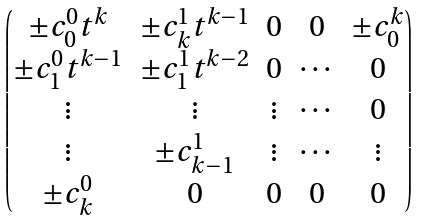<formula> <loc_0><loc_0><loc_500><loc_500>\begin{pmatrix} \pm c ^ { 0 } _ { 0 } t ^ { k } & \pm c ^ { 1 } _ { k } t ^ { k - 1 } & 0 & 0 & \pm c ^ { k } _ { 0 } \\ \pm c ^ { 0 } _ { 1 } t ^ { k - 1 } & \pm c ^ { 1 } _ { 1 } t ^ { k - 2 } & 0 & \cdots & 0 \\ \vdots & \vdots & \vdots & \cdots & 0 \\ \vdots & \pm c ^ { 1 } _ { k - 1 } & \vdots & \cdots & \vdots \\ \pm c ^ { 0 } _ { k } & 0 & 0 & 0 & 0 \end{pmatrix}</formula> 